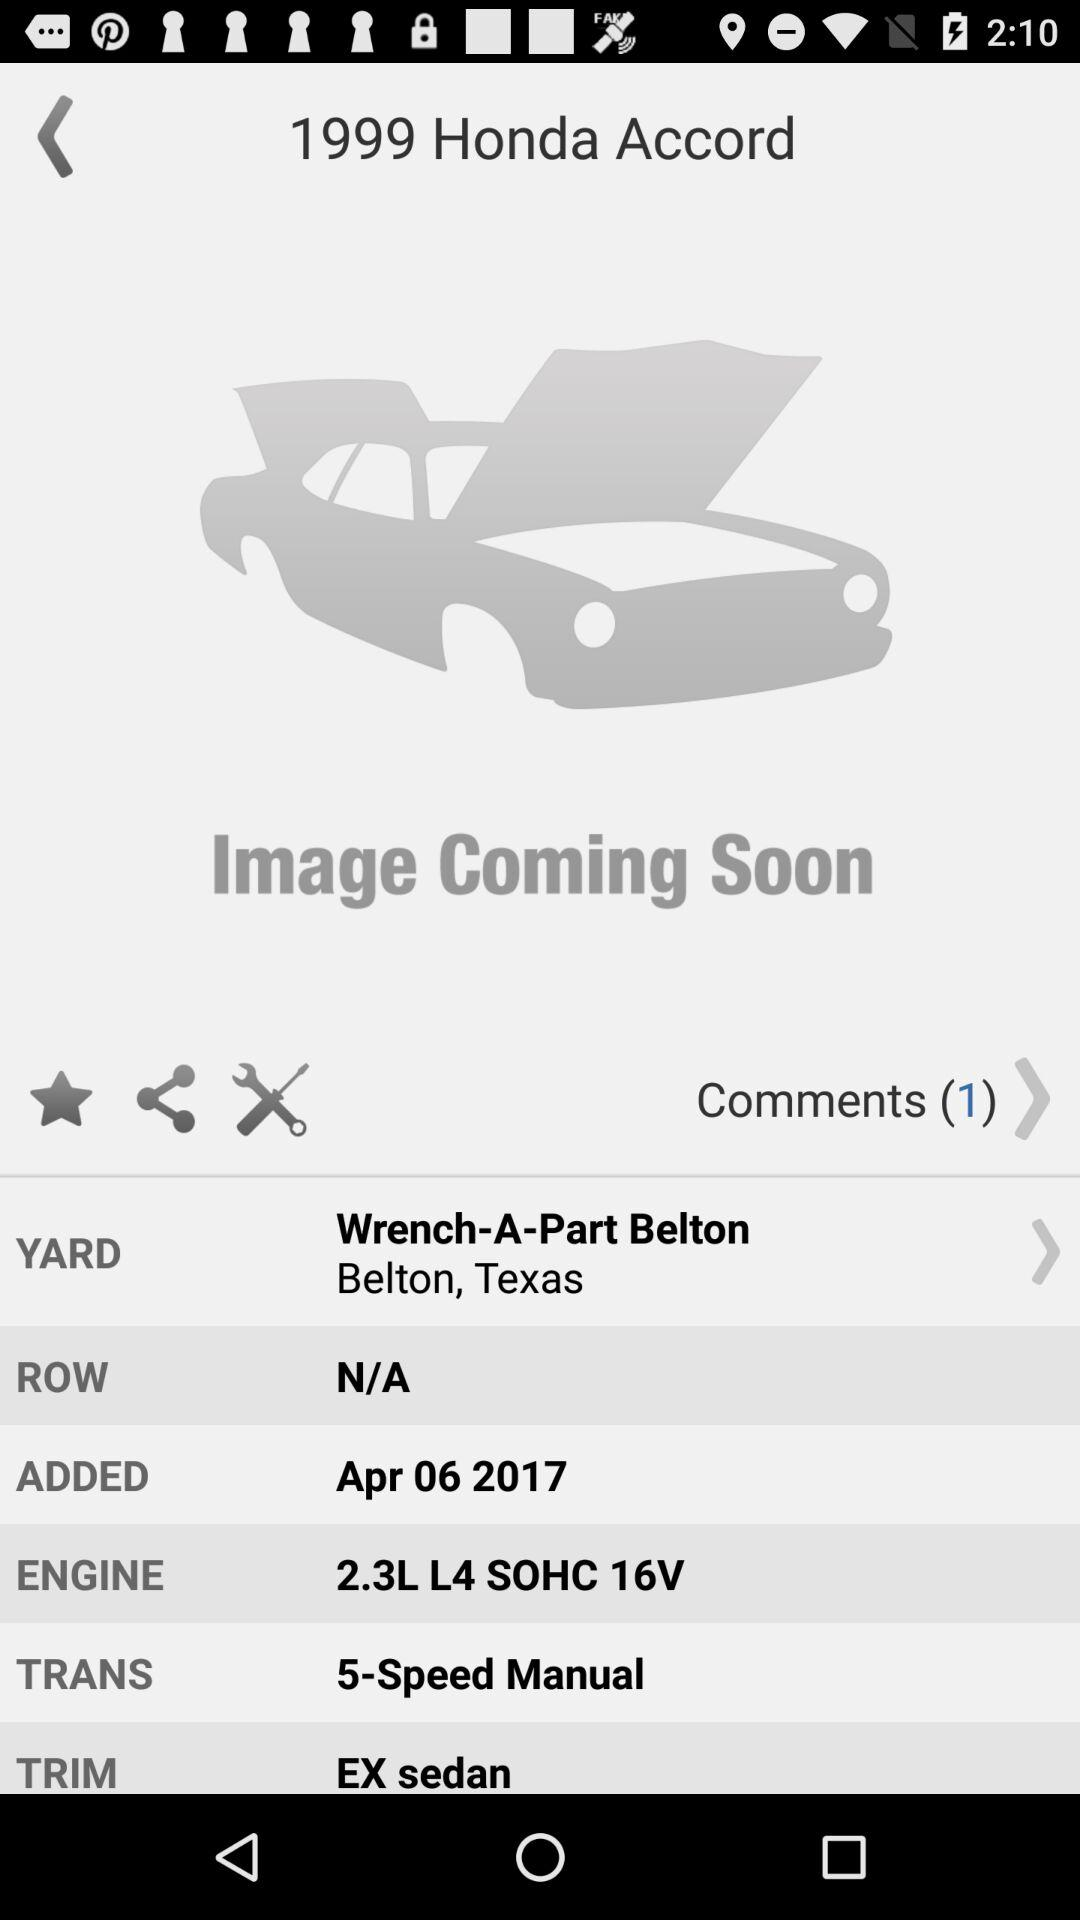What kind of transmission does this car have? The car is equipped with a 5-Speed Manual transmission, which typically offers drivers more control over vehicle performance and can be more engaging to drive compared to an automatic transmission. 